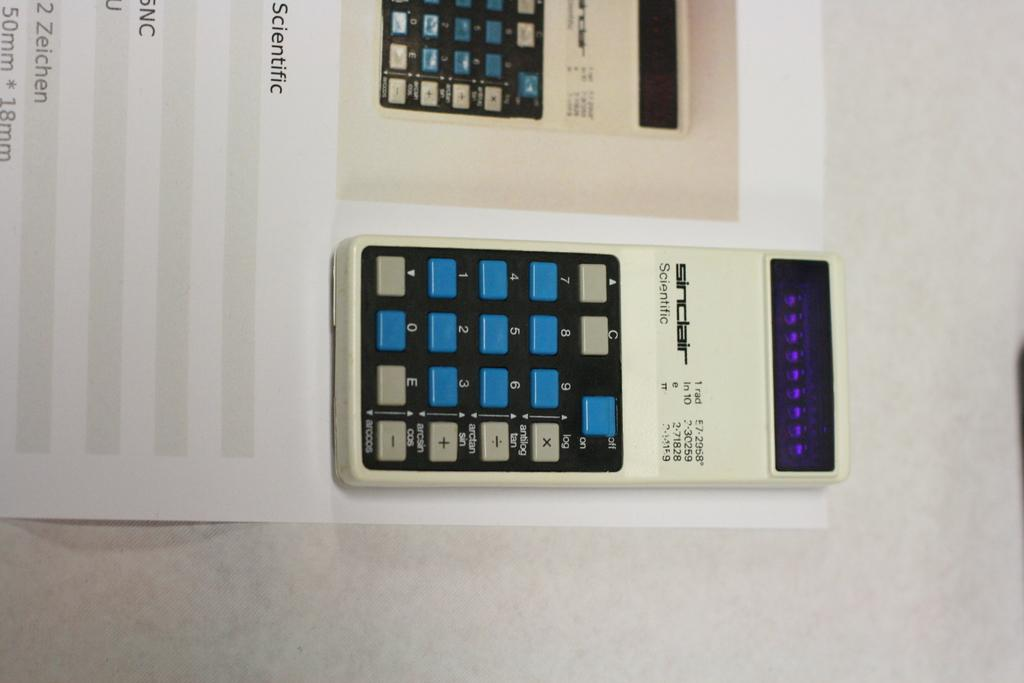<image>
Relay a brief, clear account of the picture shown. The calculator has the brand Sinclair on it's face 